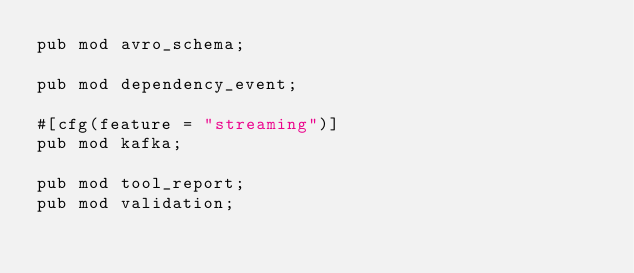Convert code to text. <code><loc_0><loc_0><loc_500><loc_500><_Rust_>pub mod avro_schema;

pub mod dependency_event;

#[cfg(feature = "streaming")]
pub mod kafka;

pub mod tool_report;
pub mod validation;
</code> 